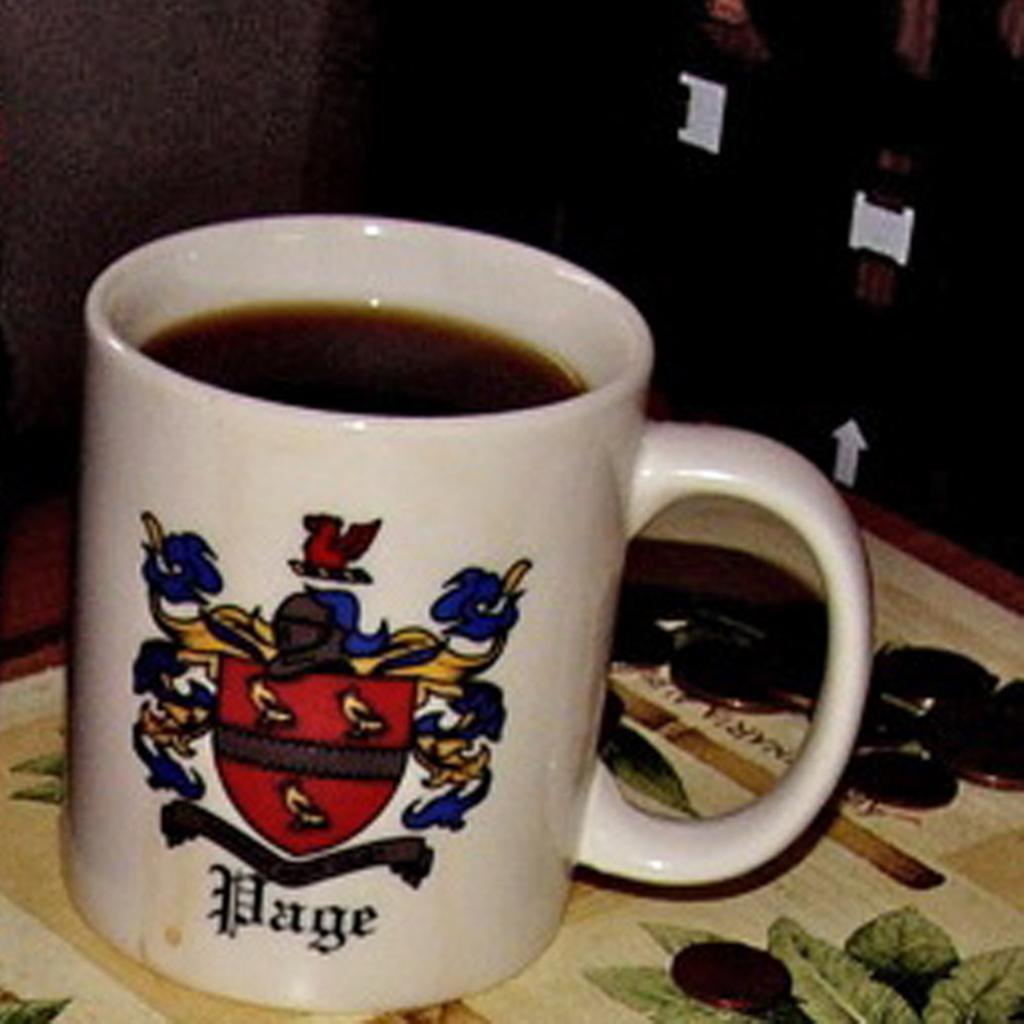Provide a one-sentence caption for the provided image. A white mug with the word Page on it is filled with coffee. 